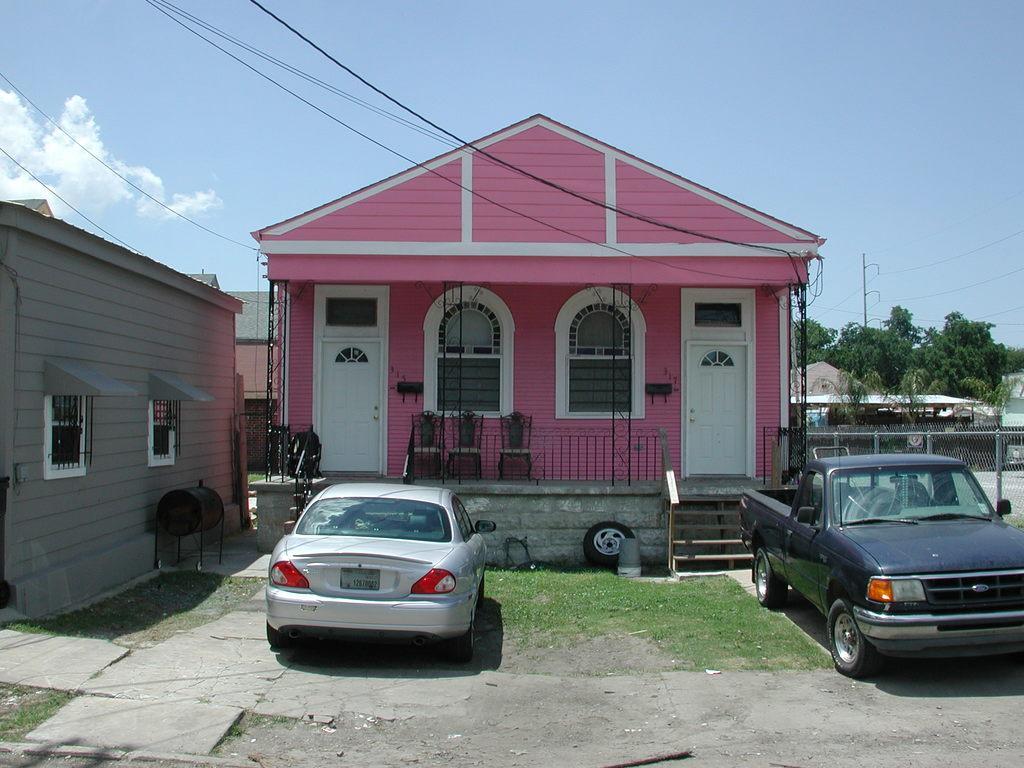Please provide a concise description of this image. In this picture there are vehicles in the foreground. At the back there are buildings and trees and there are poles and there are chairs behind the railing. In the foreground there is a staircase and wheel. At the top there is sky and there are clouds and wires. On the right side of the image there is a fence. 